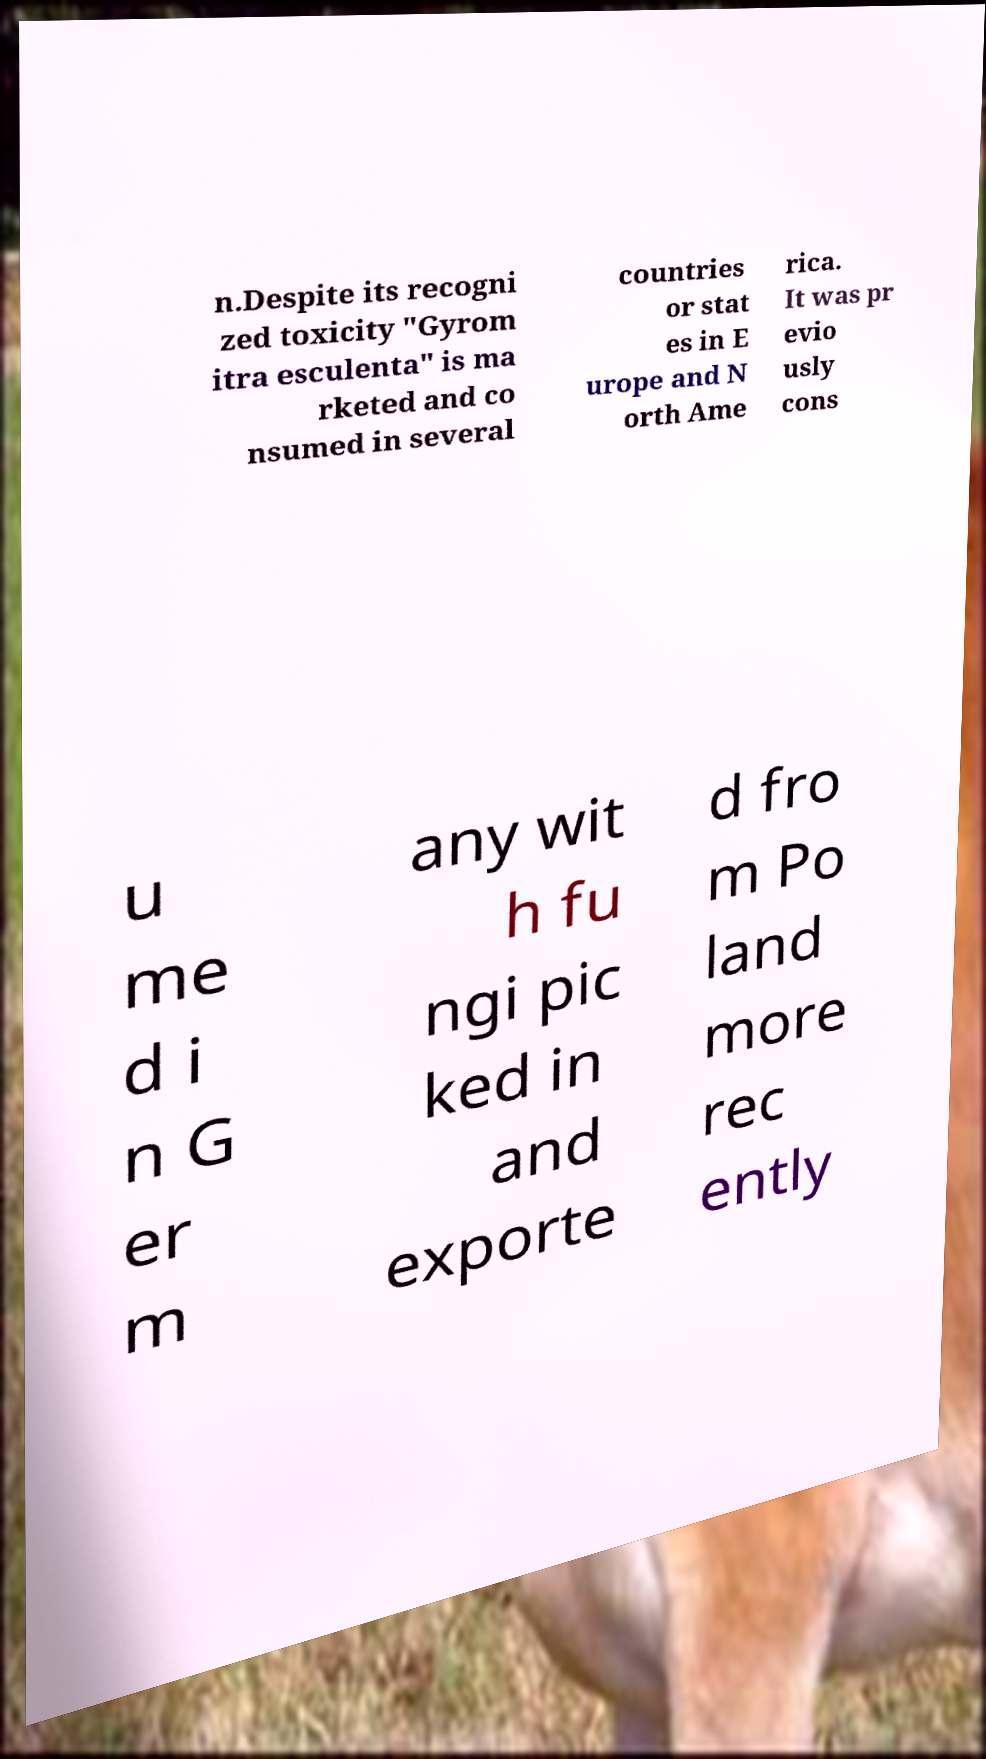Could you extract and type out the text from this image? n.Despite its recogni zed toxicity "Gyrom itra esculenta" is ma rketed and co nsumed in several countries or stat es in E urope and N orth Ame rica. It was pr evio usly cons u me d i n G er m any wit h fu ngi pic ked in and exporte d fro m Po land more rec ently 